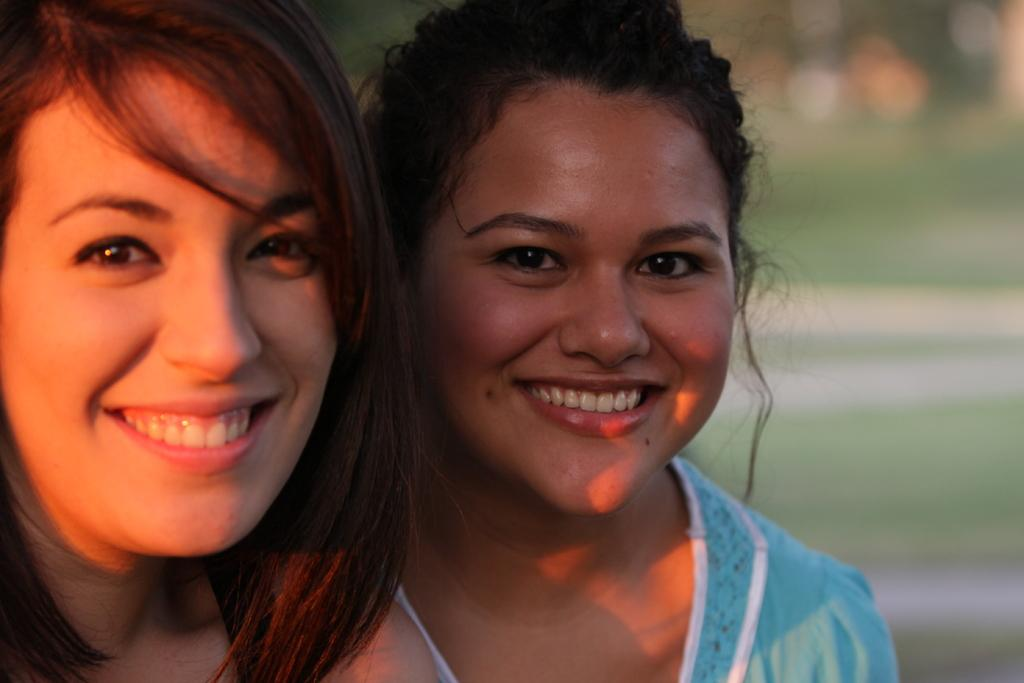How many women are in the image? There are two women in the image. What expressions do the women have? Both women are smiling. Can you describe the clothing of the woman on the right side? The woman on the right side is wearing a blue top. What can be said about the background of the image? The background of the image is blurry. Is there a stranger playing baseball in the background of the image? There is no stranger or baseball present in the image; it features two women smiling, with a blurry background. 